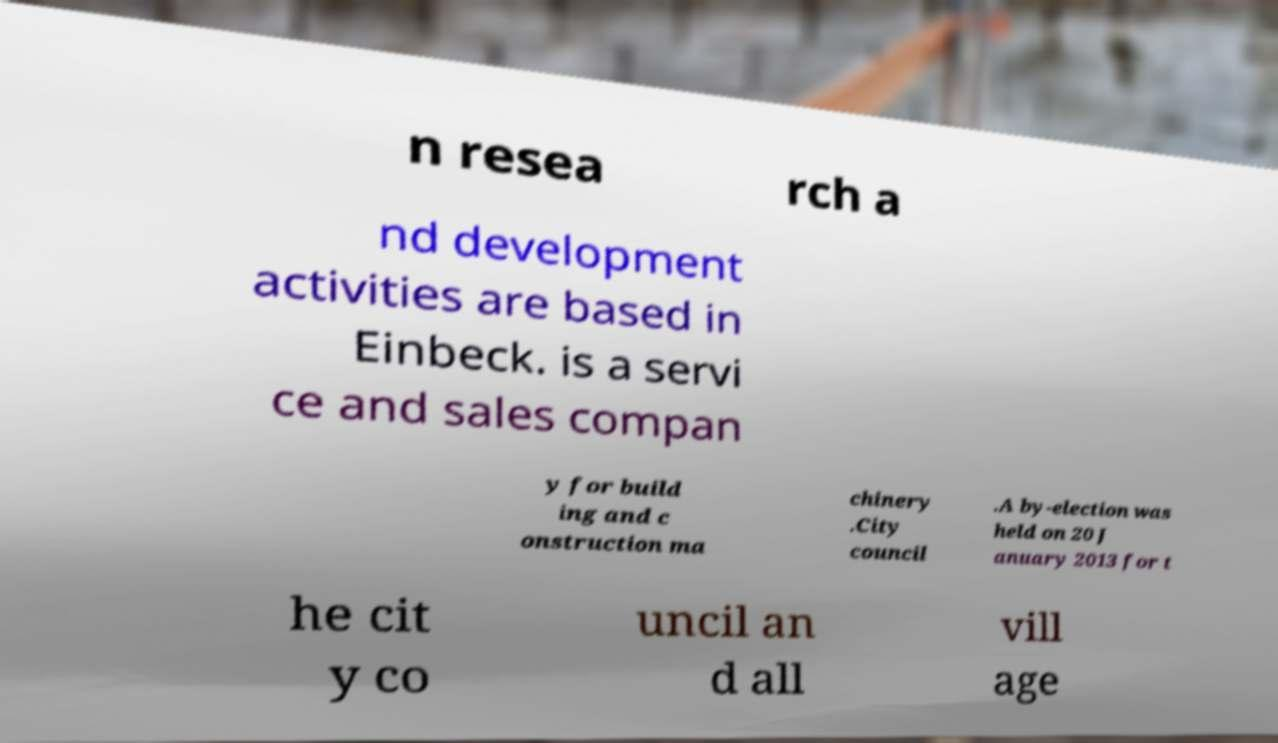For documentation purposes, I need the text within this image transcribed. Could you provide that? n resea rch a nd development activities are based in Einbeck. is a servi ce and sales compan y for build ing and c onstruction ma chinery .City council .A by-election was held on 20 J anuary 2013 for t he cit y co uncil an d all vill age 